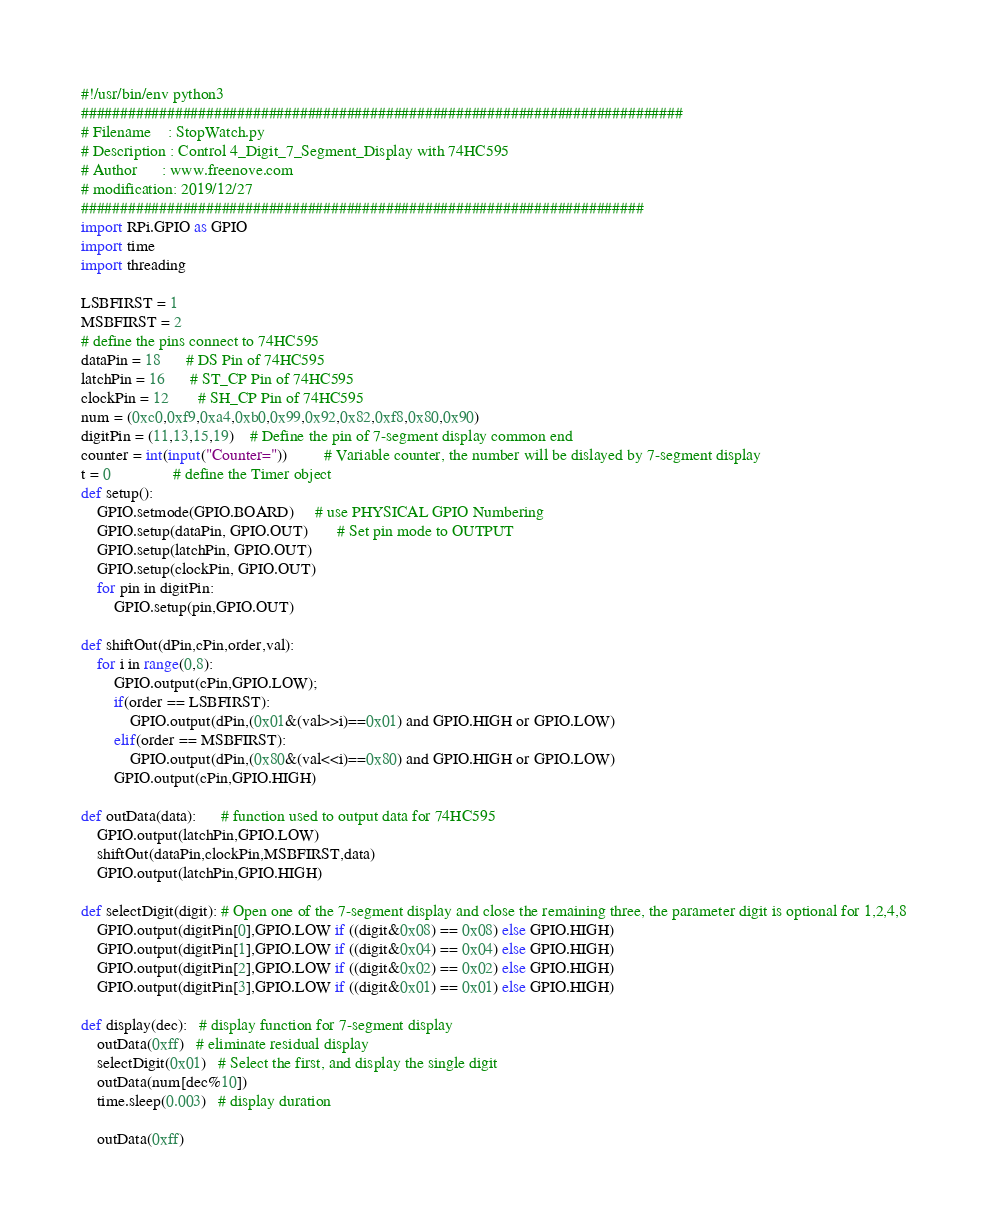<code> <loc_0><loc_0><loc_500><loc_500><_Python_>#!/usr/bin/env python3
#############################################################################
# Filename    : StopWatch.py
# Description : Control 4_Digit_7_Segment_Display with 74HC595
# Author      : www.freenove.com
# modification: 2019/12/27
########################################################################
import RPi.GPIO as GPIO
import time
import threading

LSBFIRST = 1
MSBFIRST = 2
# define the pins connect to 74HC595
dataPin = 18      # DS Pin of 74HC595
latchPin = 16      # ST_CP Pin of 74HC595
clockPin = 12       # SH_CP Pin of 74HC595
num = (0xc0,0xf9,0xa4,0xb0,0x99,0x92,0x82,0xf8,0x80,0x90)
digitPin = (11,13,15,19)    # Define the pin of 7-segment display common end
counter = int(input("Counter="))         # Variable counter, the number will be dislayed by 7-segment display
t = 0               # define the Timer object
def setup():
    GPIO.setmode(GPIO.BOARD)     # use PHYSICAL GPIO Numbering
    GPIO.setup(dataPin, GPIO.OUT)       # Set pin mode to OUTPUT
    GPIO.setup(latchPin, GPIO.OUT)
    GPIO.setup(clockPin, GPIO.OUT)
    for pin in digitPin:
        GPIO.setup(pin,GPIO.OUT)

def shiftOut(dPin,cPin,order,val):
    for i in range(0,8):
        GPIO.output(cPin,GPIO.LOW);
        if(order == LSBFIRST):
            GPIO.output(dPin,(0x01&(val>>i)==0x01) and GPIO.HIGH or GPIO.LOW)
        elif(order == MSBFIRST):
            GPIO.output(dPin,(0x80&(val<<i)==0x80) and GPIO.HIGH or GPIO.LOW)
        GPIO.output(cPin,GPIO.HIGH)

def outData(data):      # function used to output data for 74HC595
    GPIO.output(latchPin,GPIO.LOW)
    shiftOut(dataPin,clockPin,MSBFIRST,data)
    GPIO.output(latchPin,GPIO.HIGH)

def selectDigit(digit): # Open one of the 7-segment display and close the remaining three, the parameter digit is optional for 1,2,4,8
    GPIO.output(digitPin[0],GPIO.LOW if ((digit&0x08) == 0x08) else GPIO.HIGH)
    GPIO.output(digitPin[1],GPIO.LOW if ((digit&0x04) == 0x04) else GPIO.HIGH)
    GPIO.output(digitPin[2],GPIO.LOW if ((digit&0x02) == 0x02) else GPIO.HIGH)
    GPIO.output(digitPin[3],GPIO.LOW if ((digit&0x01) == 0x01) else GPIO.HIGH)

def display(dec):   # display function for 7-segment display
    outData(0xff)   # eliminate residual display
    selectDigit(0x01)   # Select the first, and display the single digit
    outData(num[dec%10])
    time.sleep(0.003)   # display duration

    outData(0xff)</code> 